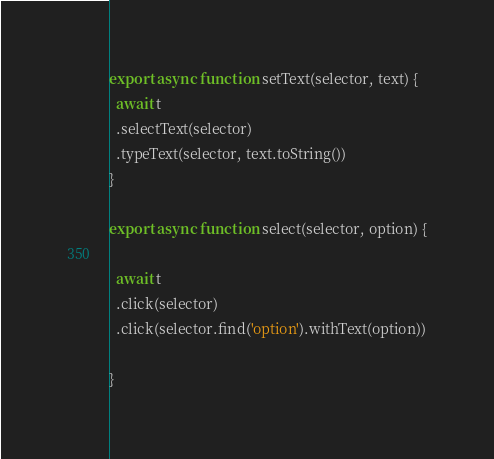Convert code to text. <code><loc_0><loc_0><loc_500><loc_500><_JavaScript_>export async function setText(selector, text) {
  await t
  .selectText(selector)
  .typeText(selector, text.toString())
}

export async function select(selector, option) {

  await t
  .click(selector)
  .click(selector.find('option').withText(option))

}
</code> 